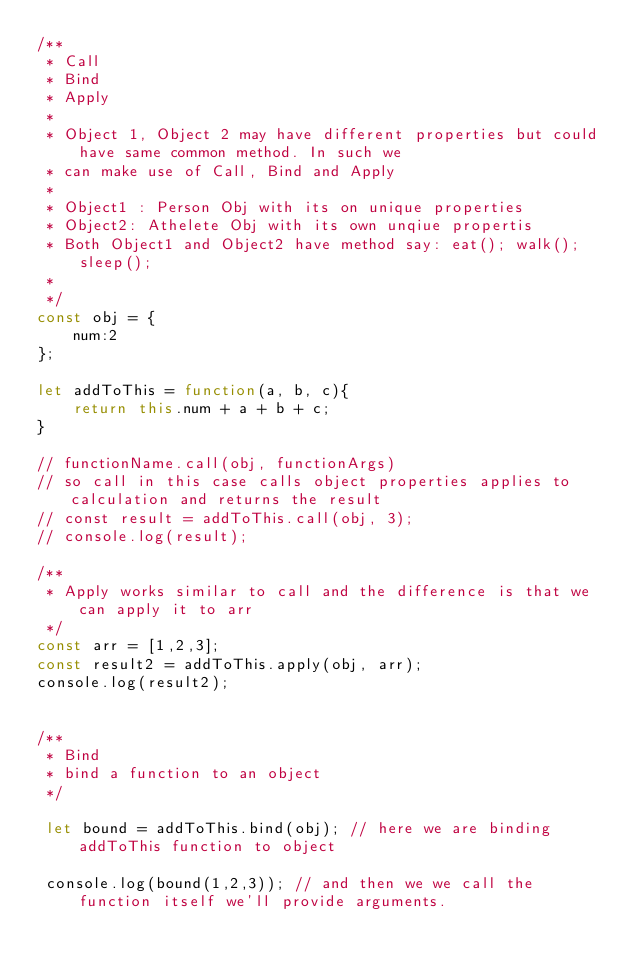<code> <loc_0><loc_0><loc_500><loc_500><_JavaScript_>/** 
 * Call 
 * Bind 
 * Apply
 * 
 * Object 1, Object 2 may have different properties but could have same common method. In such we
 * can make use of Call, Bind and Apply
 * 
 * Object1 : Person Obj with its on unique properties
 * Object2: Athelete Obj with its own unqiue propertis
 * Both Object1 and Object2 have method say: eat(); walk(); sleep();
 *  
 */
const obj = {
    num:2
};

let addToThis = function(a, b, c){
    return this.num + a + b + c;
}

// functionName.call(obj, functionArgs)
// so call in this case calls object properties applies to calculation and returns the result
// const result = addToThis.call(obj, 3);
// console.log(result);

/**
 * Apply works similar to call and the difference is that we can apply it to arr
 */
const arr = [1,2,3];
const result2 = addToThis.apply(obj, arr);
console.log(result2);


/**
 * Bind
 * bind a function to an object
 */

 let bound = addToThis.bind(obj); // here we are binding addToThis function to object

 console.log(bound(1,2,3)); // and then we we call the function itself we'll provide arguments.
</code> 